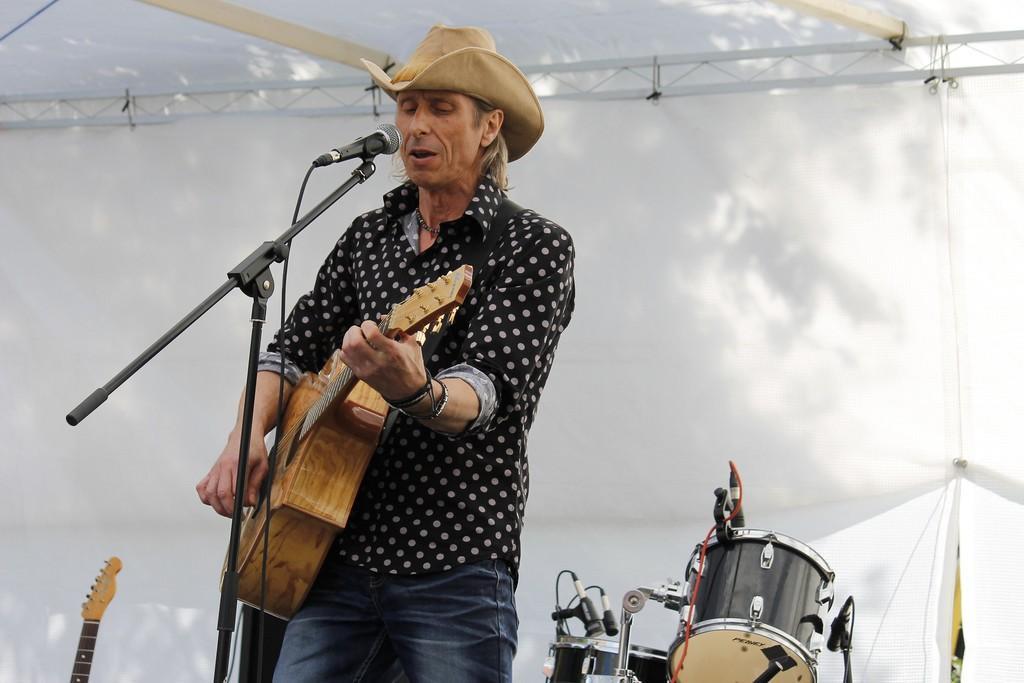In one or two sentences, can you explain what this image depicts? This picture shows a man wearing a hat and holding a guitar in his hand. He is playing. He is singing in front of a microphone and a stand. In the background, there is a drum and a cloth here. 